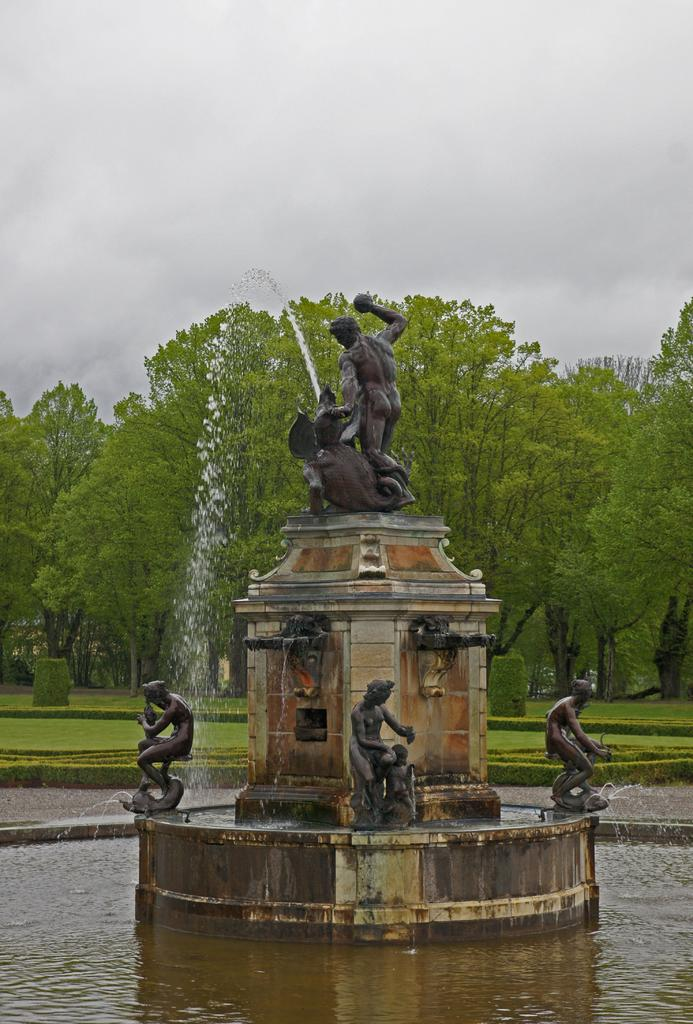What type of objects can be seen in the image? There are statues in the image. What natural feature is present in the image? There is a waterfall in the image. What can be seen on the ground in the image? The ground is visible in the image. What type of vegetation is present in the image? There is grass, plants, and trees in the image. What part of the natural environment is visible in the image? The sky is visible in the image. Can you see any toes in the image? There are no toes visible in the image. What type of fruit is hanging from the trees in the image? There is no fruit, including bananas, hanging from the trees in the image. 